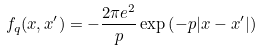Convert formula to latex. <formula><loc_0><loc_0><loc_500><loc_500>f _ { q } ( x , x ^ { \prime } ) = - \frac { 2 \pi e ^ { 2 } } { p } \exp \left ( - p | x - x ^ { \prime } | \right )</formula> 